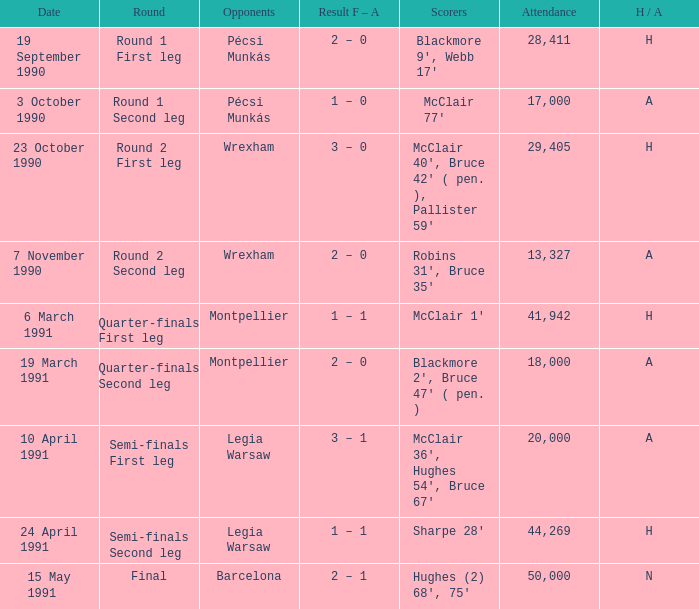What is the lowest attendance when the h/A is H in the Semi-Finals Second Leg? 44269.0. 